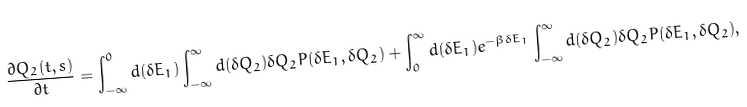<formula> <loc_0><loc_0><loc_500><loc_500>\frac { \partial Q _ { 2 } ( t , s ) } { \partial t } = \int _ { - \infty } ^ { 0 } d ( \delta E _ { 1 } ) \int _ { - \infty } ^ { \infty } d ( \delta Q _ { 2 } ) \delta Q _ { 2 } P ( \delta E _ { 1 } , \delta Q _ { 2 } ) + \int _ { 0 } ^ { \infty } d ( \delta E _ { 1 } ) e ^ { - \beta \delta E _ { 1 } } \int _ { - \infty } ^ { \infty } d ( \delta Q _ { 2 } ) \delta Q _ { 2 } P ( \delta E _ { 1 } , \delta Q _ { 2 } ) ,</formula> 